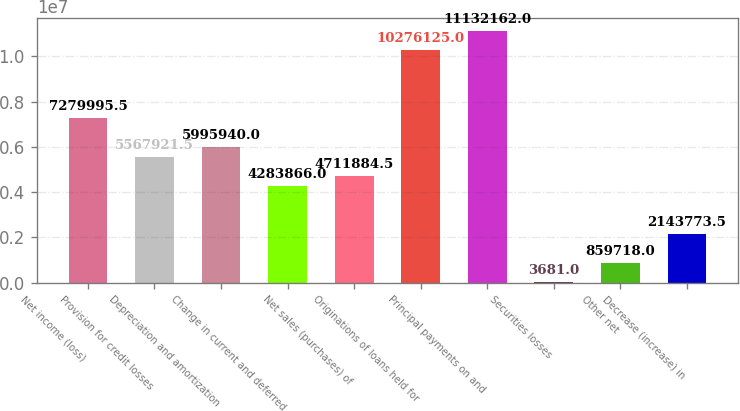Convert chart. <chart><loc_0><loc_0><loc_500><loc_500><bar_chart><fcel>Net income (loss)<fcel>Provision for credit losses<fcel>Depreciation and amortization<fcel>Change in current and deferred<fcel>Net sales (purchases) of<fcel>Originations of loans held for<fcel>Principal payments on and<fcel>Securities losses<fcel>Other net<fcel>Decrease (increase) in<nl><fcel>7.28e+06<fcel>5.56792e+06<fcel>5.99594e+06<fcel>4.28387e+06<fcel>4.71188e+06<fcel>1.02761e+07<fcel>1.11322e+07<fcel>3681<fcel>859718<fcel>2.14377e+06<nl></chart> 